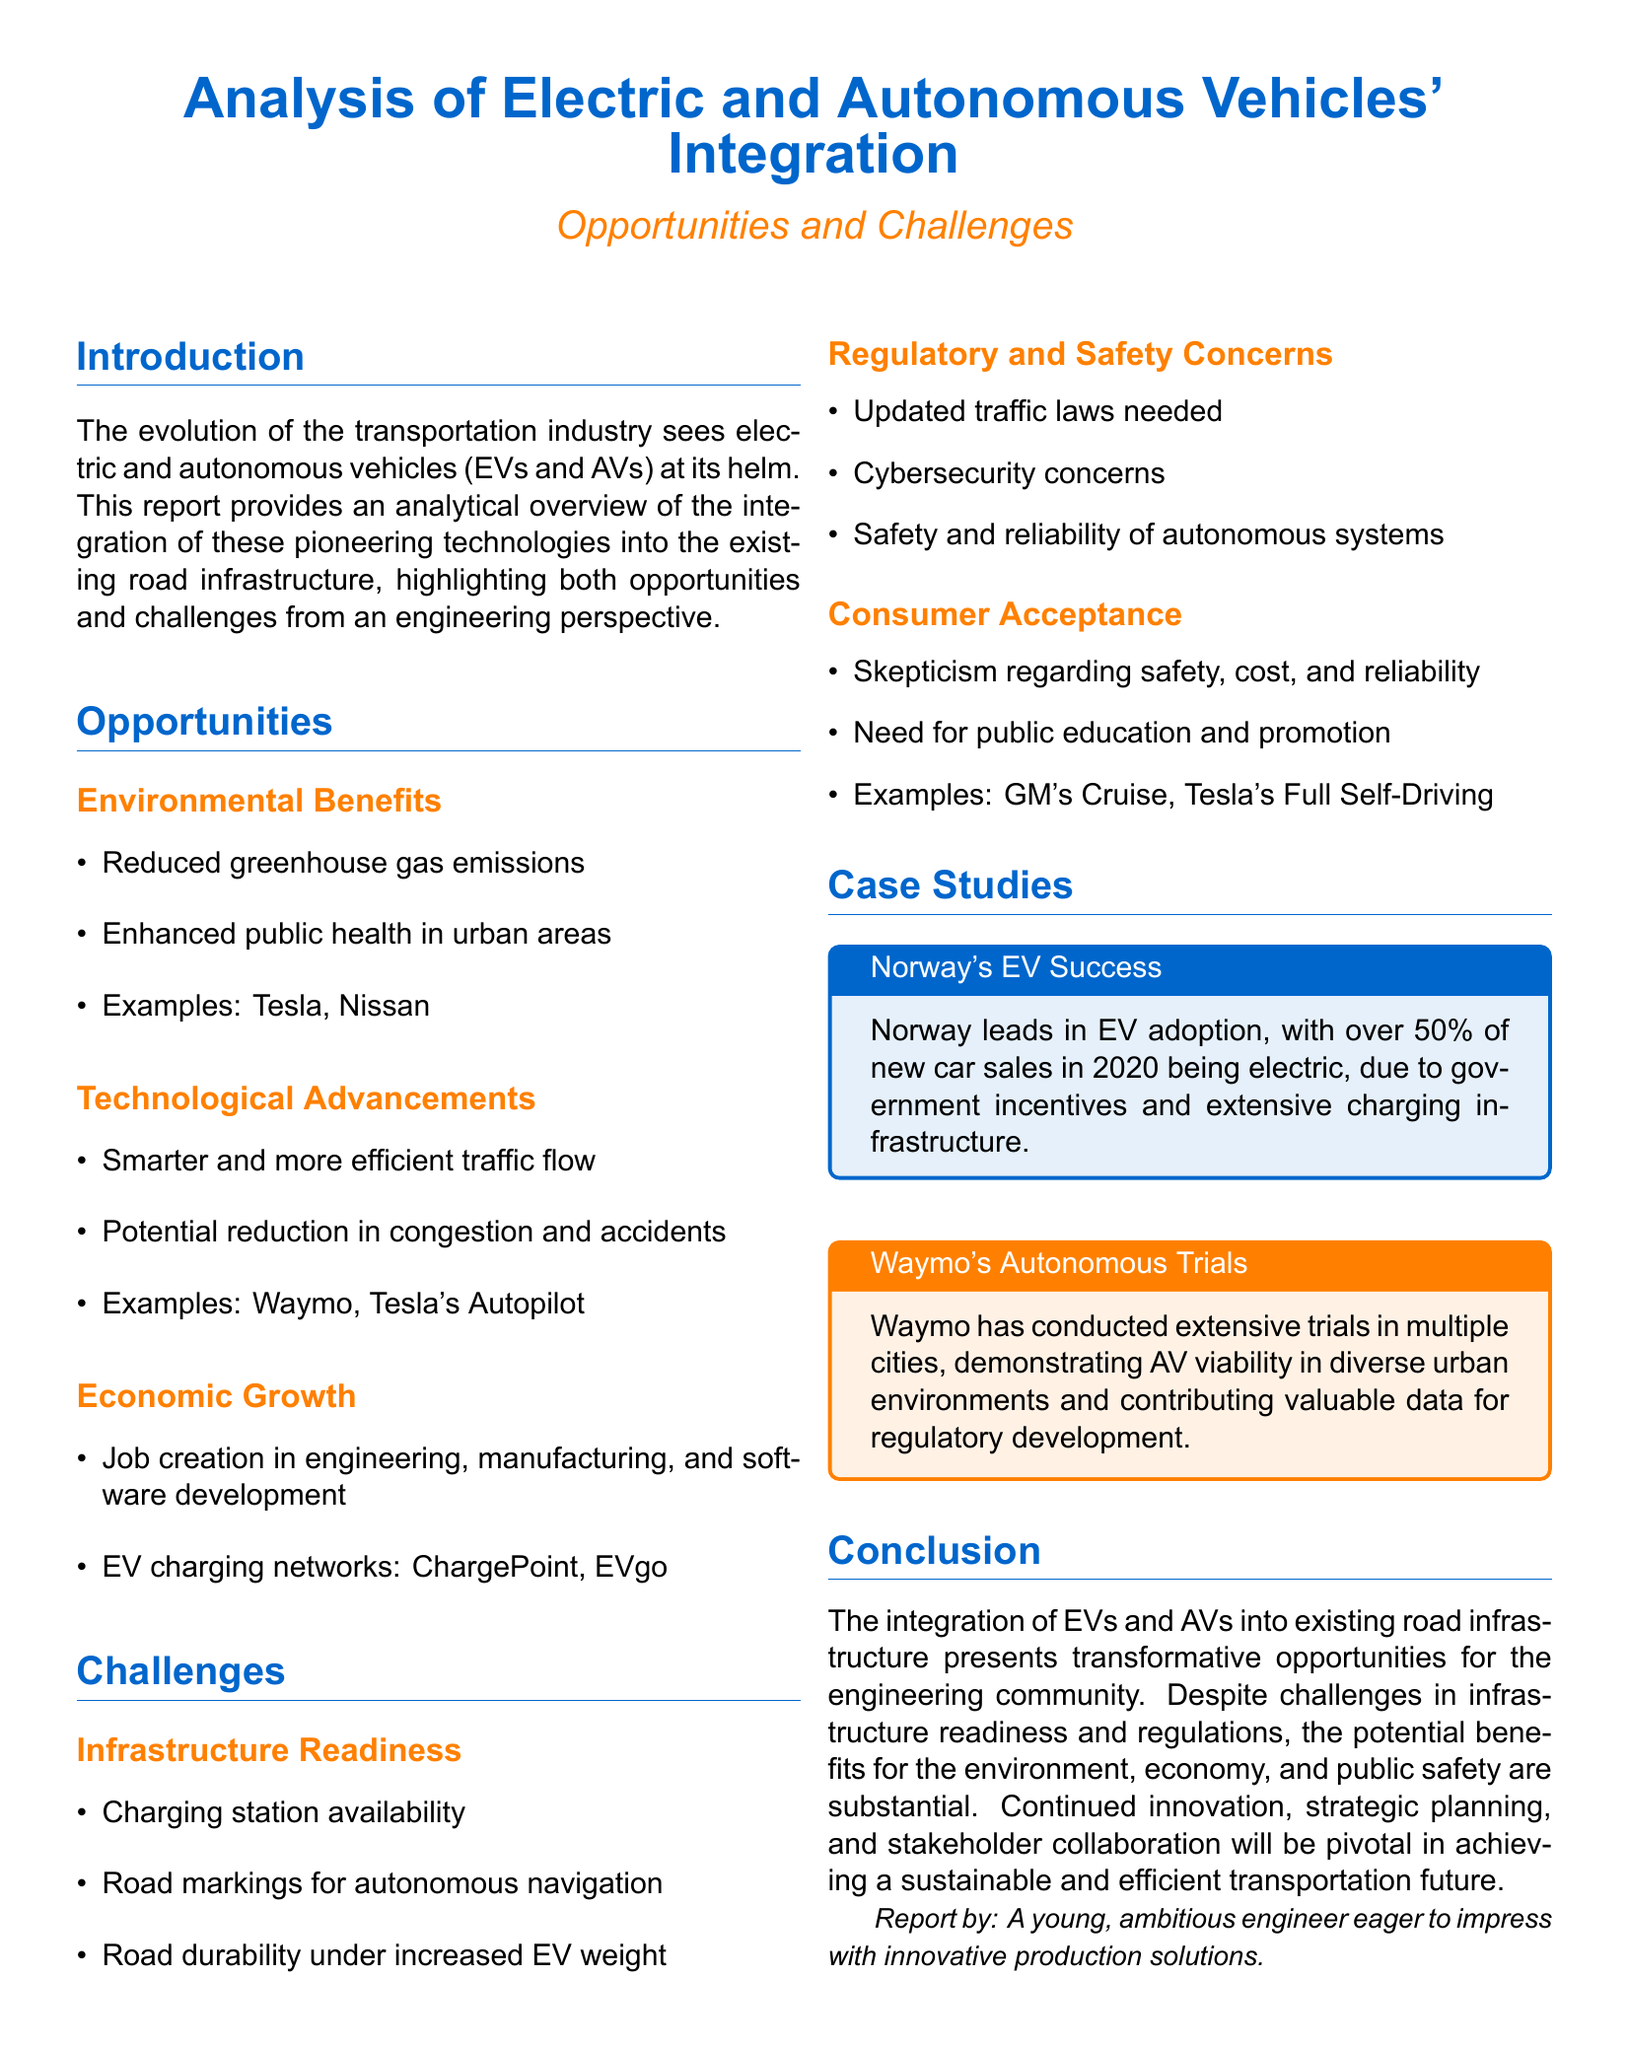What percentage of new car sales in Norway were electric in 2020? The document states that over 50% of new car sales in Norway in 2020 were electric.
Answer: over 50% What are two environmental benefits of EV integration? The document lists reduced greenhouse gas emissions and enhanced public health as environmental benefits.
Answer: Reduced greenhouse gas emissions, enhanced public health Which company conducted extensive trials for autonomous vehicles? The report mentions Waymo as the company that has conducted extensive trials in multiple cities.
Answer: Waymo What is one example of a company involved in EV charging networks? The document lists ChargePoint as one example of a company providing EV charging networks.
Answer: ChargePoint What major challenge relates to infrastructure readiness? The document indicates that charging station availability is a significant challenge in terms of infrastructure readiness.
Answer: Charging station availability What is a key factor needed for consumer acceptance of AVs? The report highlights the need for public education and promotion as a key factor for consumer acceptance of AVs.
Answer: Public education and promotion How does the report describe the potential impact of EVs and AVs on traffic flow? The document discusses smarter and more efficient traffic flow as a potential impact of EVs and AVs.
Answer: Smarter and more efficient traffic flow What is one regulatory concern mentioned regarding EVs and AVs? The report states that updated traffic laws are a regulatory concern related to EVs and AVs.
Answer: Updated traffic laws 